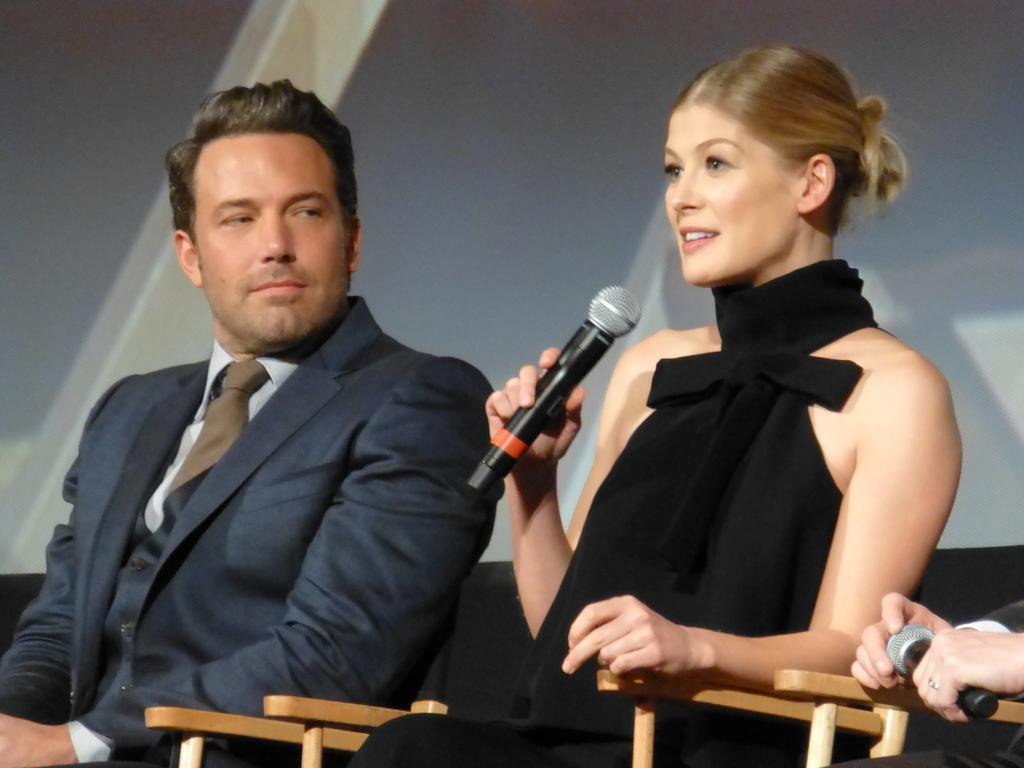What is the woman in the image holding? The woman is holding a microphone. What is the woman's position in the image? The woman is sitting on a chair. Who else is present in the image? There is a man and at least one other person sitting on chairs. What can be seen in the background of the image? There is a screen visible in the background. What type of doll is sitting on the mine in the image? There is no doll or mine present in the image. 